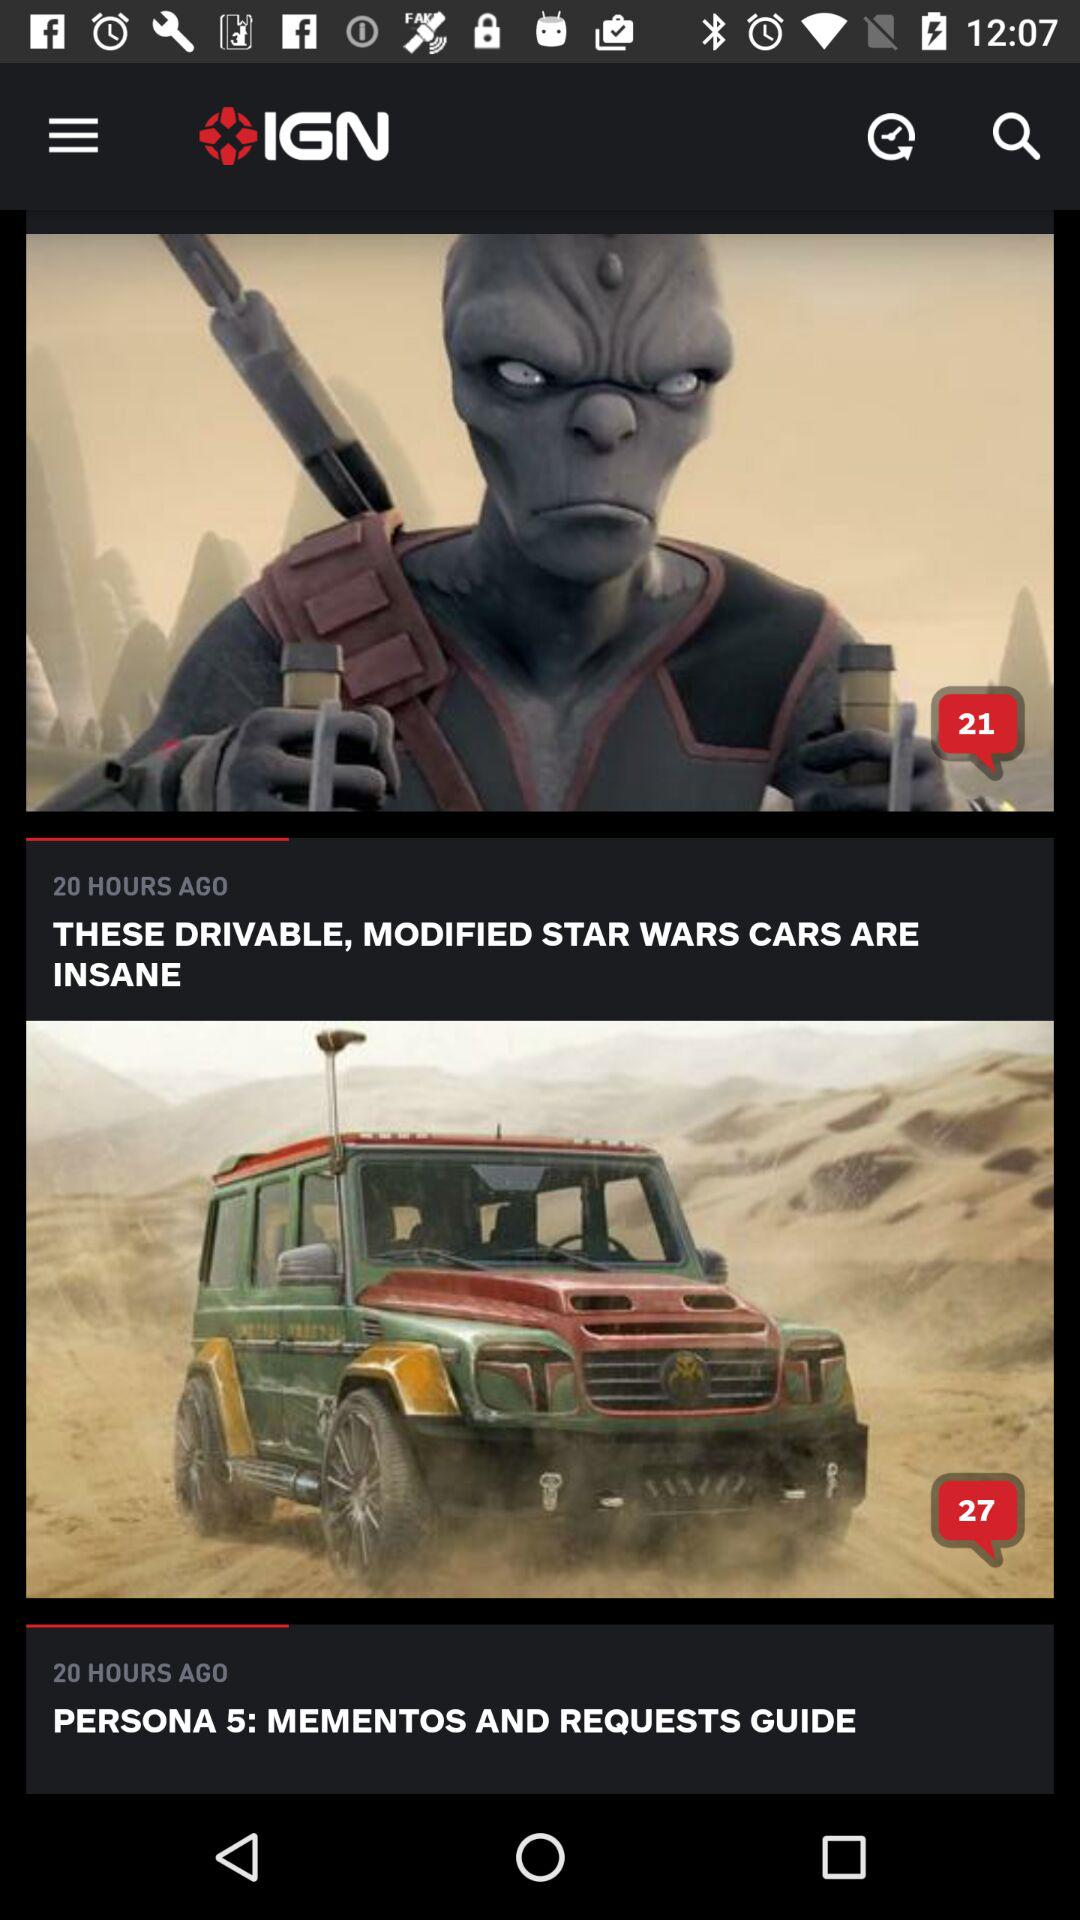How many hours ago was the first article published?
Answer the question using a single word or phrase. 20 